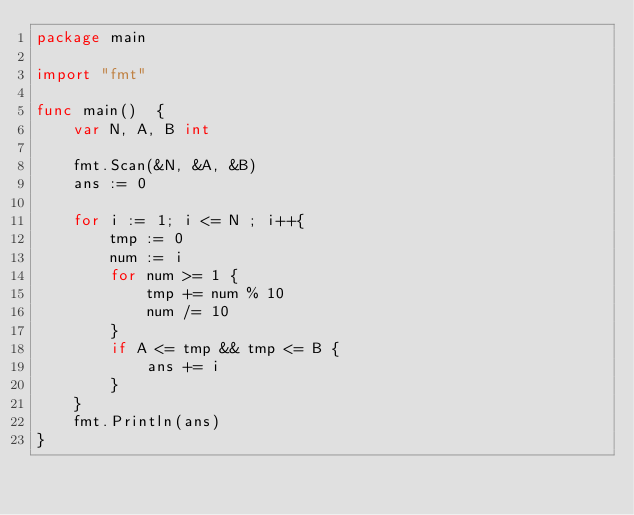<code> <loc_0><loc_0><loc_500><loc_500><_Go_>package main

import "fmt"

func main()  {
	var N, A, B int

	fmt.Scan(&N, &A, &B)
	ans := 0

	for i := 1; i <= N ; i++{
		tmp := 0
		num := i
		for num >= 1 {
			tmp += num % 10
			num /= 10
		}
		if A <= tmp && tmp <= B {
			ans += i
		}
	}
	fmt.Println(ans)
}</code> 